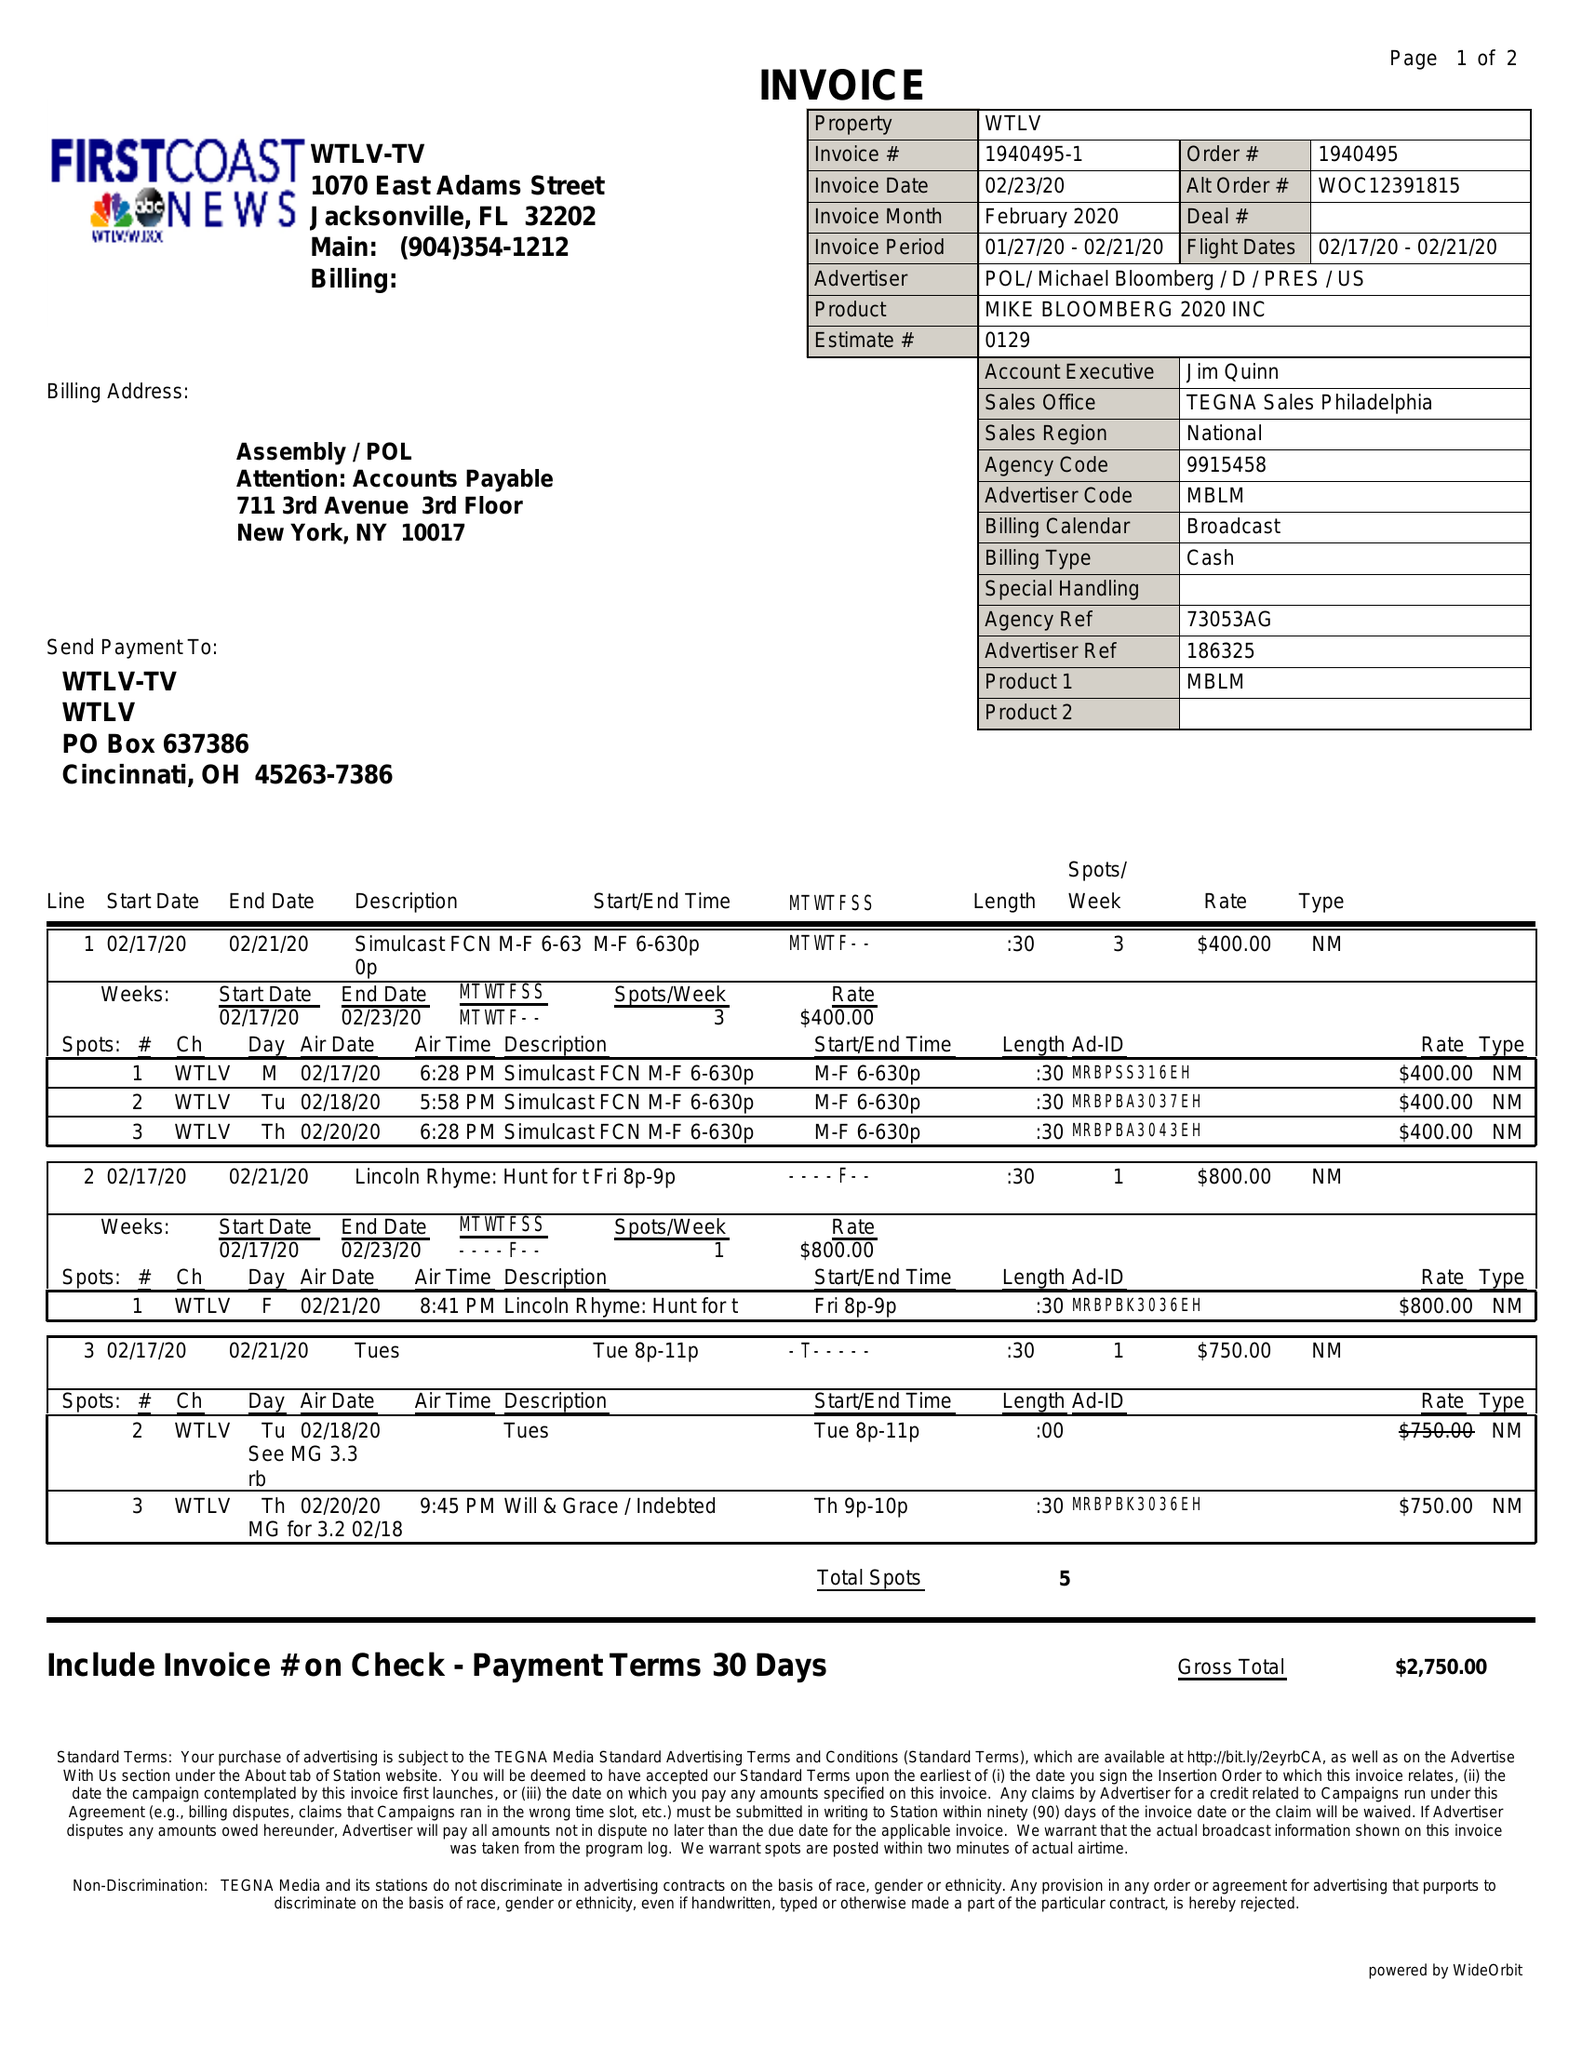What is the value for the gross_amount?
Answer the question using a single word or phrase. 2750.00 